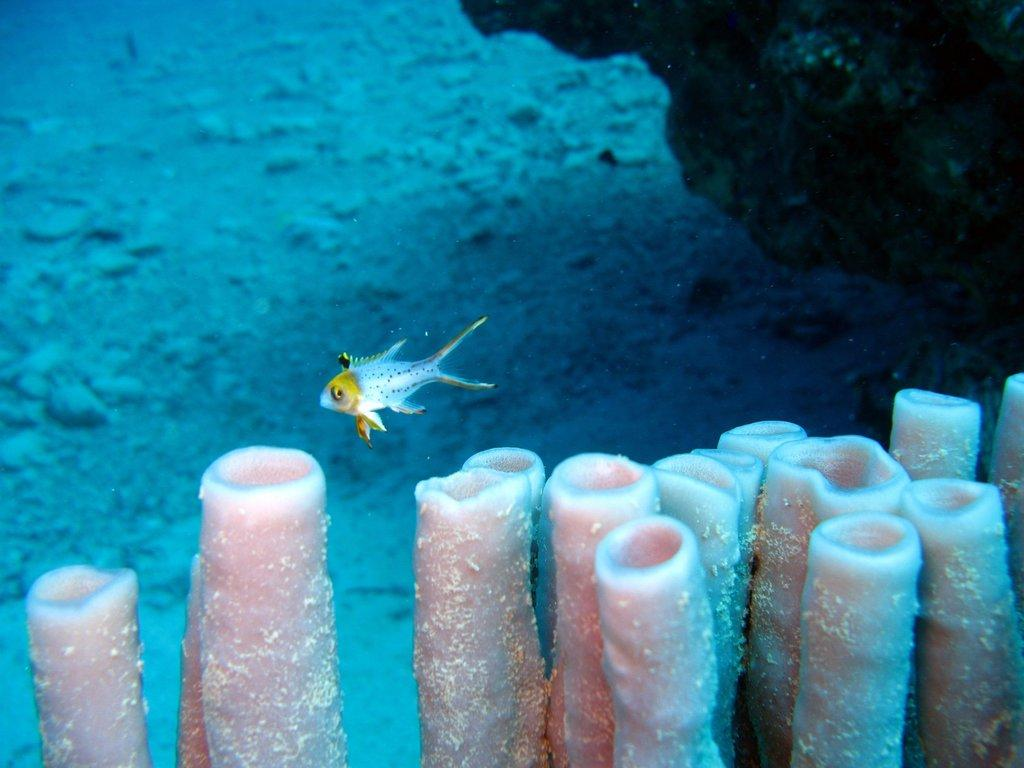What type of animal can be seen in the water in the image? There is a fish in the water in the image. What else can be seen at the bottom of the image? There are plants visible at the bottom of the image. What type of noise can be heard coming from the fish in the image? Fish do not make noise that can be heard by humans, so there is no noise coming from the fish in the image. 